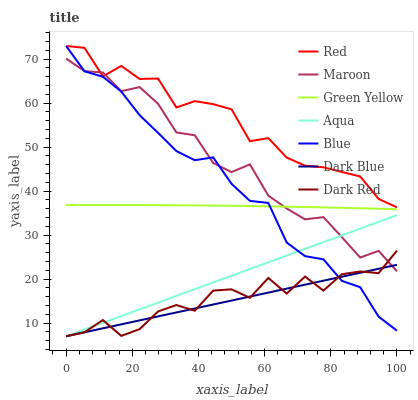Does Dark Blue have the minimum area under the curve?
Answer yes or no. Yes. Does Red have the maximum area under the curve?
Answer yes or no. Yes. Does Dark Red have the minimum area under the curve?
Answer yes or no. No. Does Dark Red have the maximum area under the curve?
Answer yes or no. No. Is Aqua the smoothest?
Answer yes or no. Yes. Is Dark Red the roughest?
Answer yes or no. Yes. Is Dark Red the smoothest?
Answer yes or no. No. Is Aqua the roughest?
Answer yes or no. No. Does Dark Red have the lowest value?
Answer yes or no. Yes. Does Maroon have the lowest value?
Answer yes or no. No. Does Red have the highest value?
Answer yes or no. Yes. Does Dark Red have the highest value?
Answer yes or no. No. Is Aqua less than Red?
Answer yes or no. Yes. Is Green Yellow greater than Dark Blue?
Answer yes or no. Yes. Does Maroon intersect Blue?
Answer yes or no. Yes. Is Maroon less than Blue?
Answer yes or no. No. Is Maroon greater than Blue?
Answer yes or no. No. Does Aqua intersect Red?
Answer yes or no. No. 